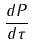Convert formula to latex. <formula><loc_0><loc_0><loc_500><loc_500>\frac { d P } { d \tau }</formula> 